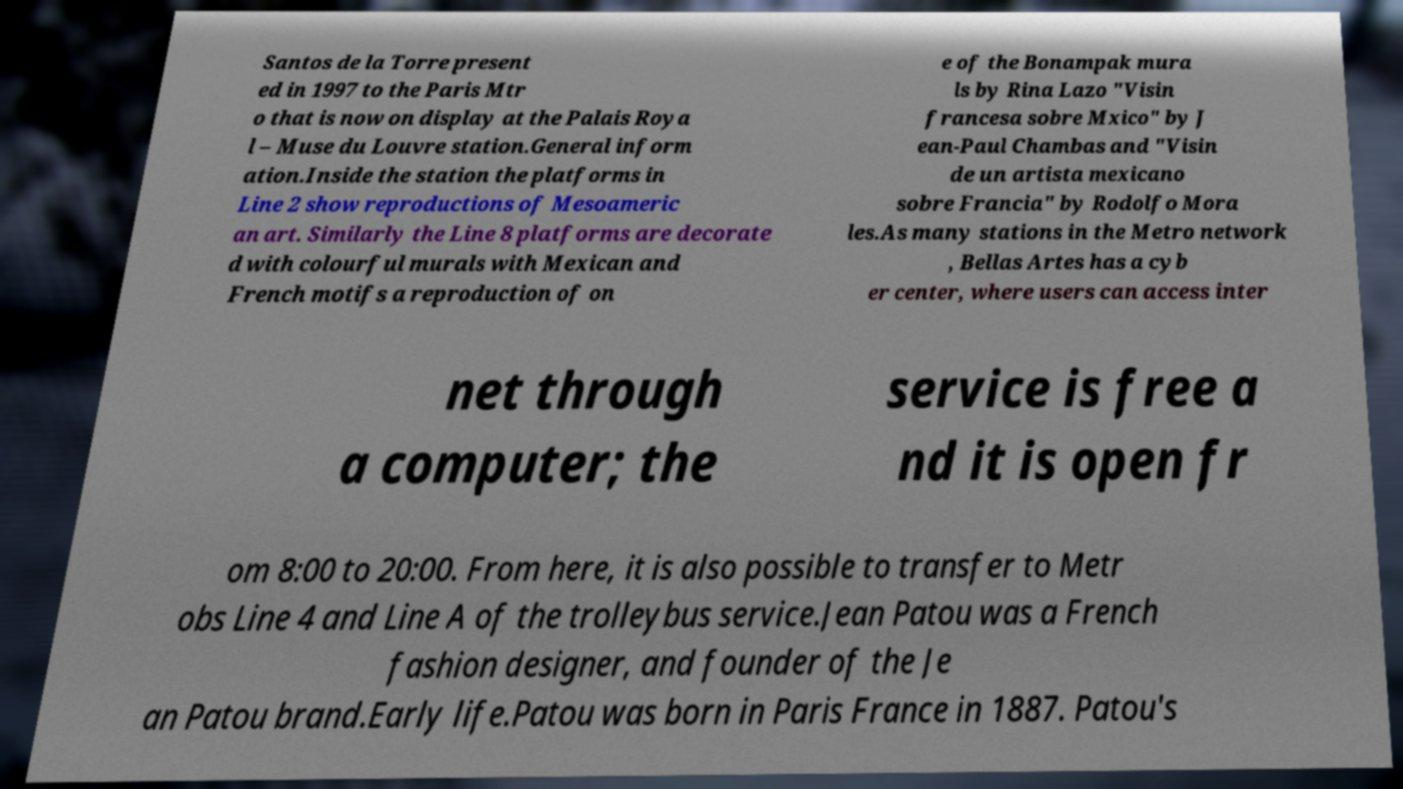What messages or text are displayed in this image? I need them in a readable, typed format. Santos de la Torre present ed in 1997 to the Paris Mtr o that is now on display at the Palais Roya l – Muse du Louvre station.General inform ation.Inside the station the platforms in Line 2 show reproductions of Mesoameric an art. Similarly the Line 8 platforms are decorate d with colourful murals with Mexican and French motifs a reproduction of on e of the Bonampak mura ls by Rina Lazo "Visin francesa sobre Mxico" by J ean-Paul Chambas and "Visin de un artista mexicano sobre Francia" by Rodolfo Mora les.As many stations in the Metro network , Bellas Artes has a cyb er center, where users can access inter net through a computer; the service is free a nd it is open fr om 8:00 to 20:00. From here, it is also possible to transfer to Metr obs Line 4 and Line A of the trolleybus service.Jean Patou was a French fashion designer, and founder of the Je an Patou brand.Early life.Patou was born in Paris France in 1887. Patou's 